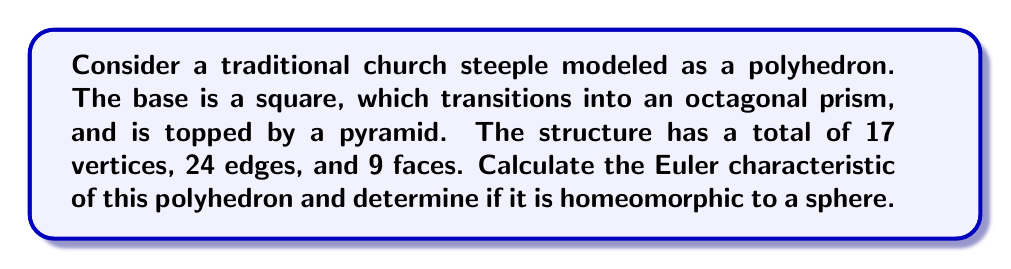Can you answer this question? To solve this problem, we'll follow these steps:

1) Recall the Euler characteristic formula for polyhedra:
   
   $$ \chi = V - E + F $$
   
   where $\chi$ is the Euler characteristic, $V$ is the number of vertices, $E$ is the number of edges, and $F$ is the number of faces.

2) We are given:
   - Vertices (V) = 17
   - Edges (E) = 24
   - Faces (F) = 9

3) Let's substitute these values into the formula:

   $$ \chi = 17 - 24 + 9 $$

4) Simplify:
   $$ \chi = 2 $$

5) Now, recall that any polyhedron homeomorphic to a sphere has an Euler characteristic of 2.

6) Since our calculated Euler characteristic is 2, this polyhedron is indeed homeomorphic to a sphere.

This result aligns with our intuition about the structure of a church steeple. Despite its complex shape, topologically it's equivalent to a sphere - there are no holes or handles that would change its fundamental shape.

This example shows how the beauty and complexity of traditional architecture can be understood through the lens of mathematical topology, preserving our cultural heritage while deepening our understanding of it.
Answer: The Euler characteristic of the church steeple polyhedron is 2, and it is homeomorphic to a sphere. 